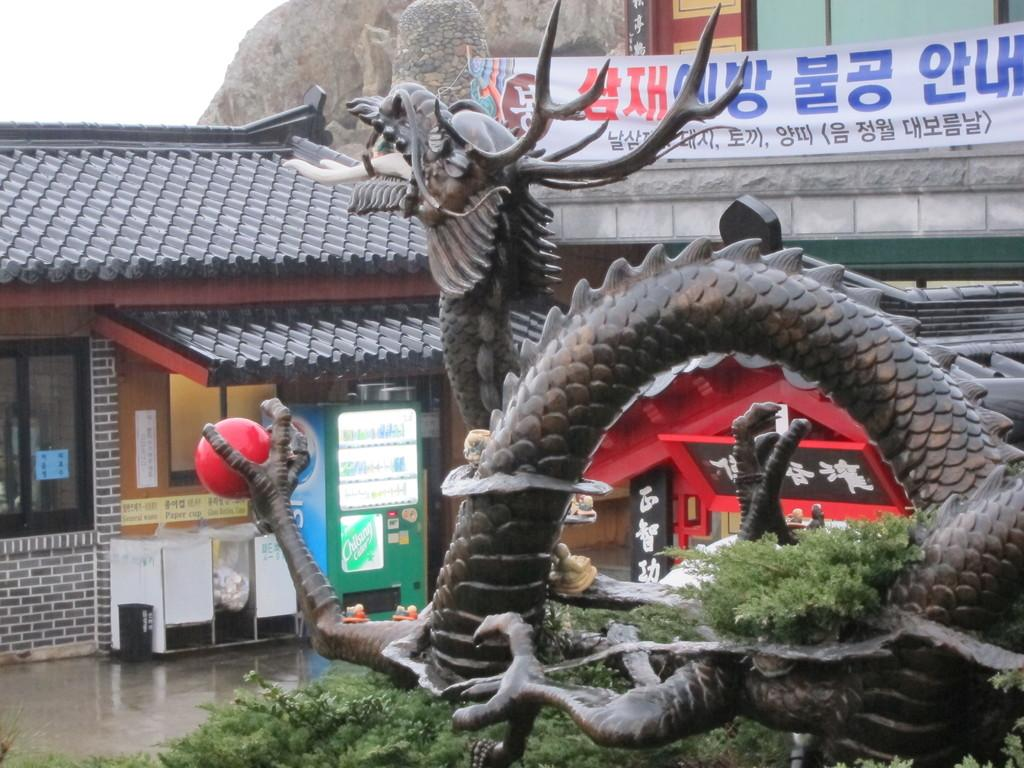What is the main subject of the image? There is a statue of a dragon in the image. What else can be seen in the image besides the dragon statue? There are plants, houses, a banner, a refrigerator, a rock, and other items in the image. What is the background of the image? The sky is visible in the background of the image. What type of watch is the dragon wearing in the image? There is no watch visible on the dragon in the image. Is there a battle taking place between the dragon and other creatures in the image? There is no battle depicted in the image; it only shows a statue of a dragon and other objects. 